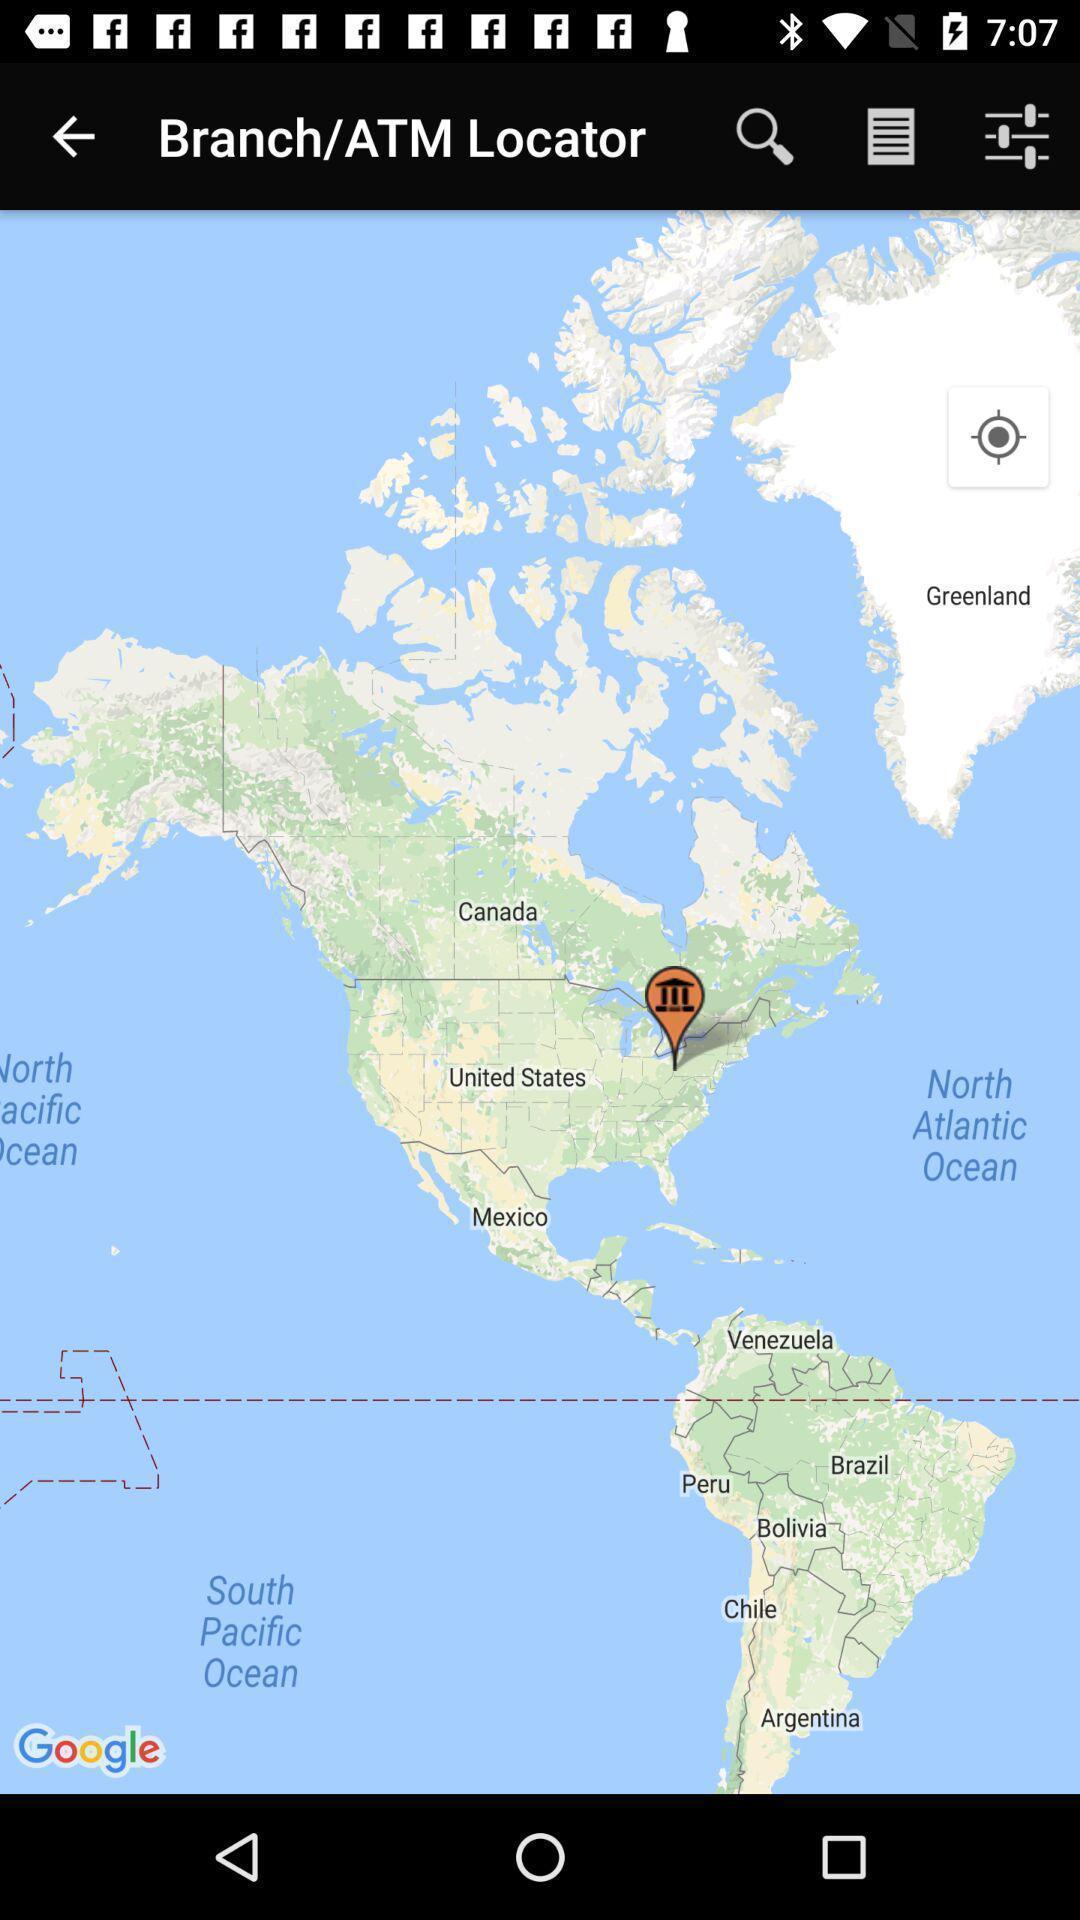Summarize the main components in this picture. Screen showing search bar to find bank locations. 